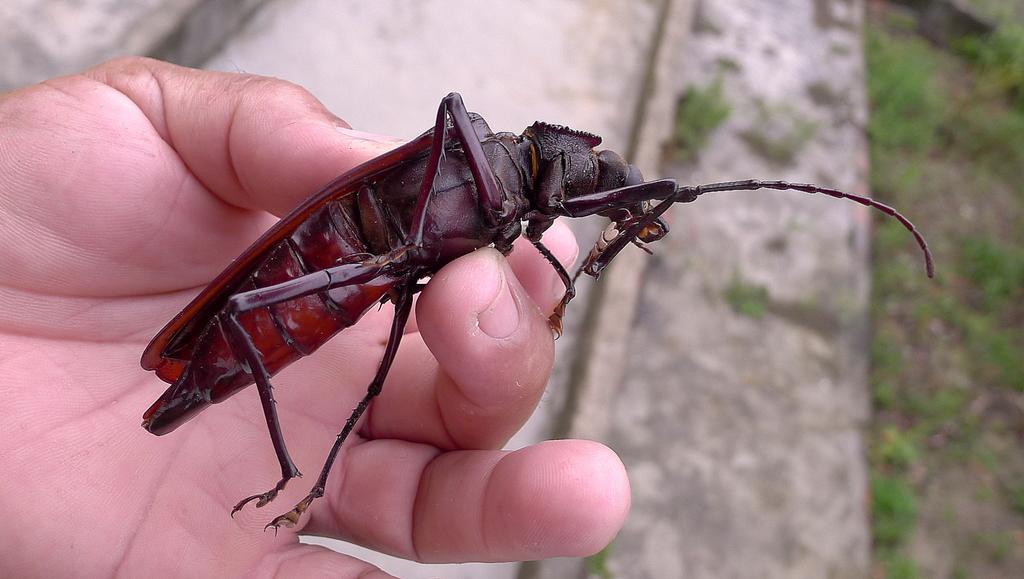In one or two sentences, can you explain what this image depicts? In this image we can see some person holding an insect. In the background we can see the land and also grass. 